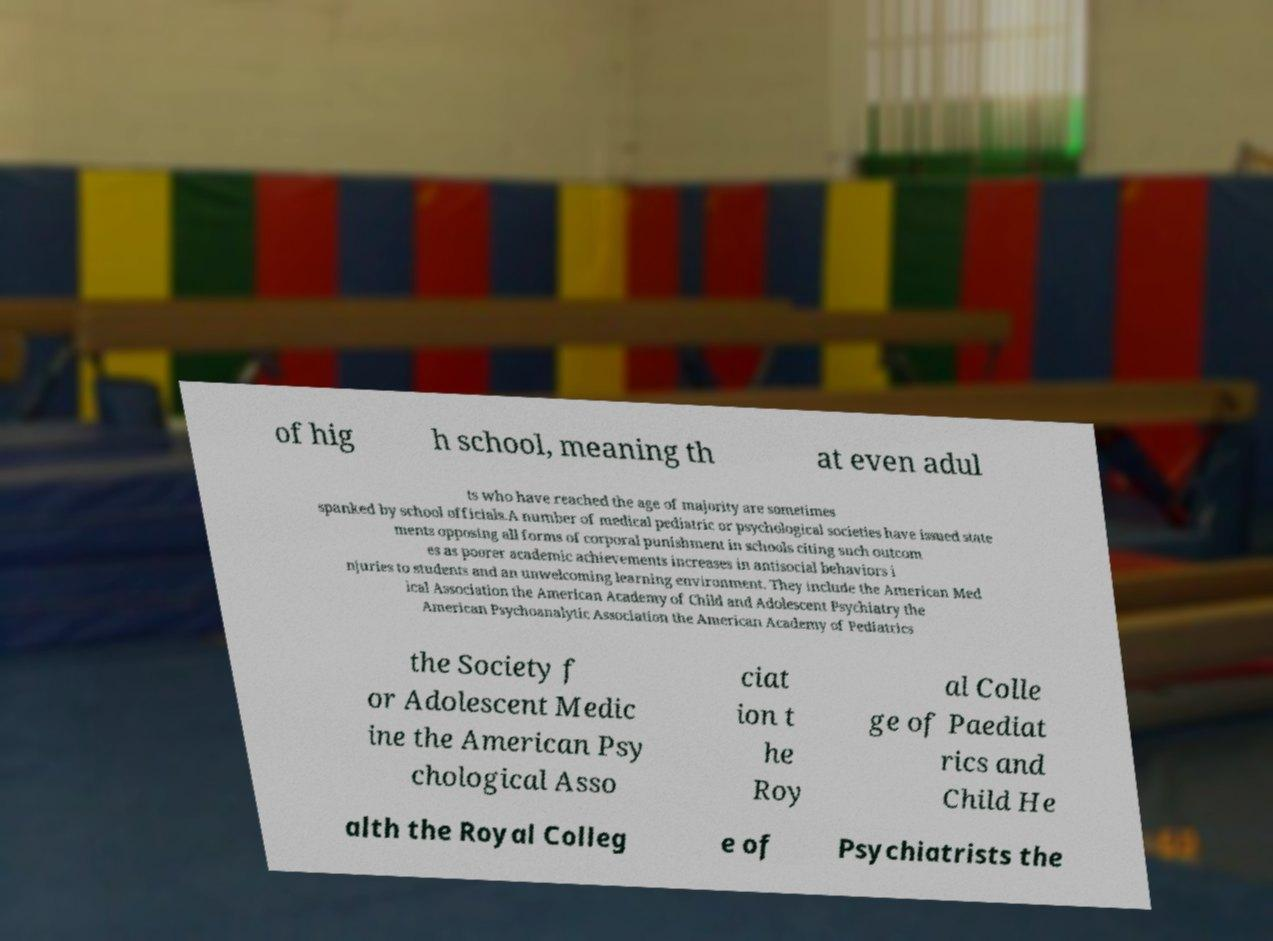What messages or text are displayed in this image? I need them in a readable, typed format. of hig h school, meaning th at even adul ts who have reached the age of majority are sometimes spanked by school officials.A number of medical pediatric or psychological societies have issued state ments opposing all forms of corporal punishment in schools citing such outcom es as poorer academic achievements increases in antisocial behaviors i njuries to students and an unwelcoming learning environment. They include the American Med ical Association the American Academy of Child and Adolescent Psychiatry the American Psychoanalytic Association the American Academy of Pediatrics the Society f or Adolescent Medic ine the American Psy chological Asso ciat ion t he Roy al Colle ge of Paediat rics and Child He alth the Royal Colleg e of Psychiatrists the 